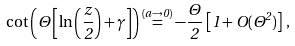Convert formula to latex. <formula><loc_0><loc_0><loc_500><loc_500>\cot \left ( \Theta \left [ \ln \left ( \frac { z } { 2 } \right ) + \gamma \right ] \right ) \stackrel { ( a \rightarrow 0 ) } { = } - \frac { \Theta } { 2 } \, \left [ 1 + O ( \Theta ^ { 2 } ) \right ] \, ,</formula> 